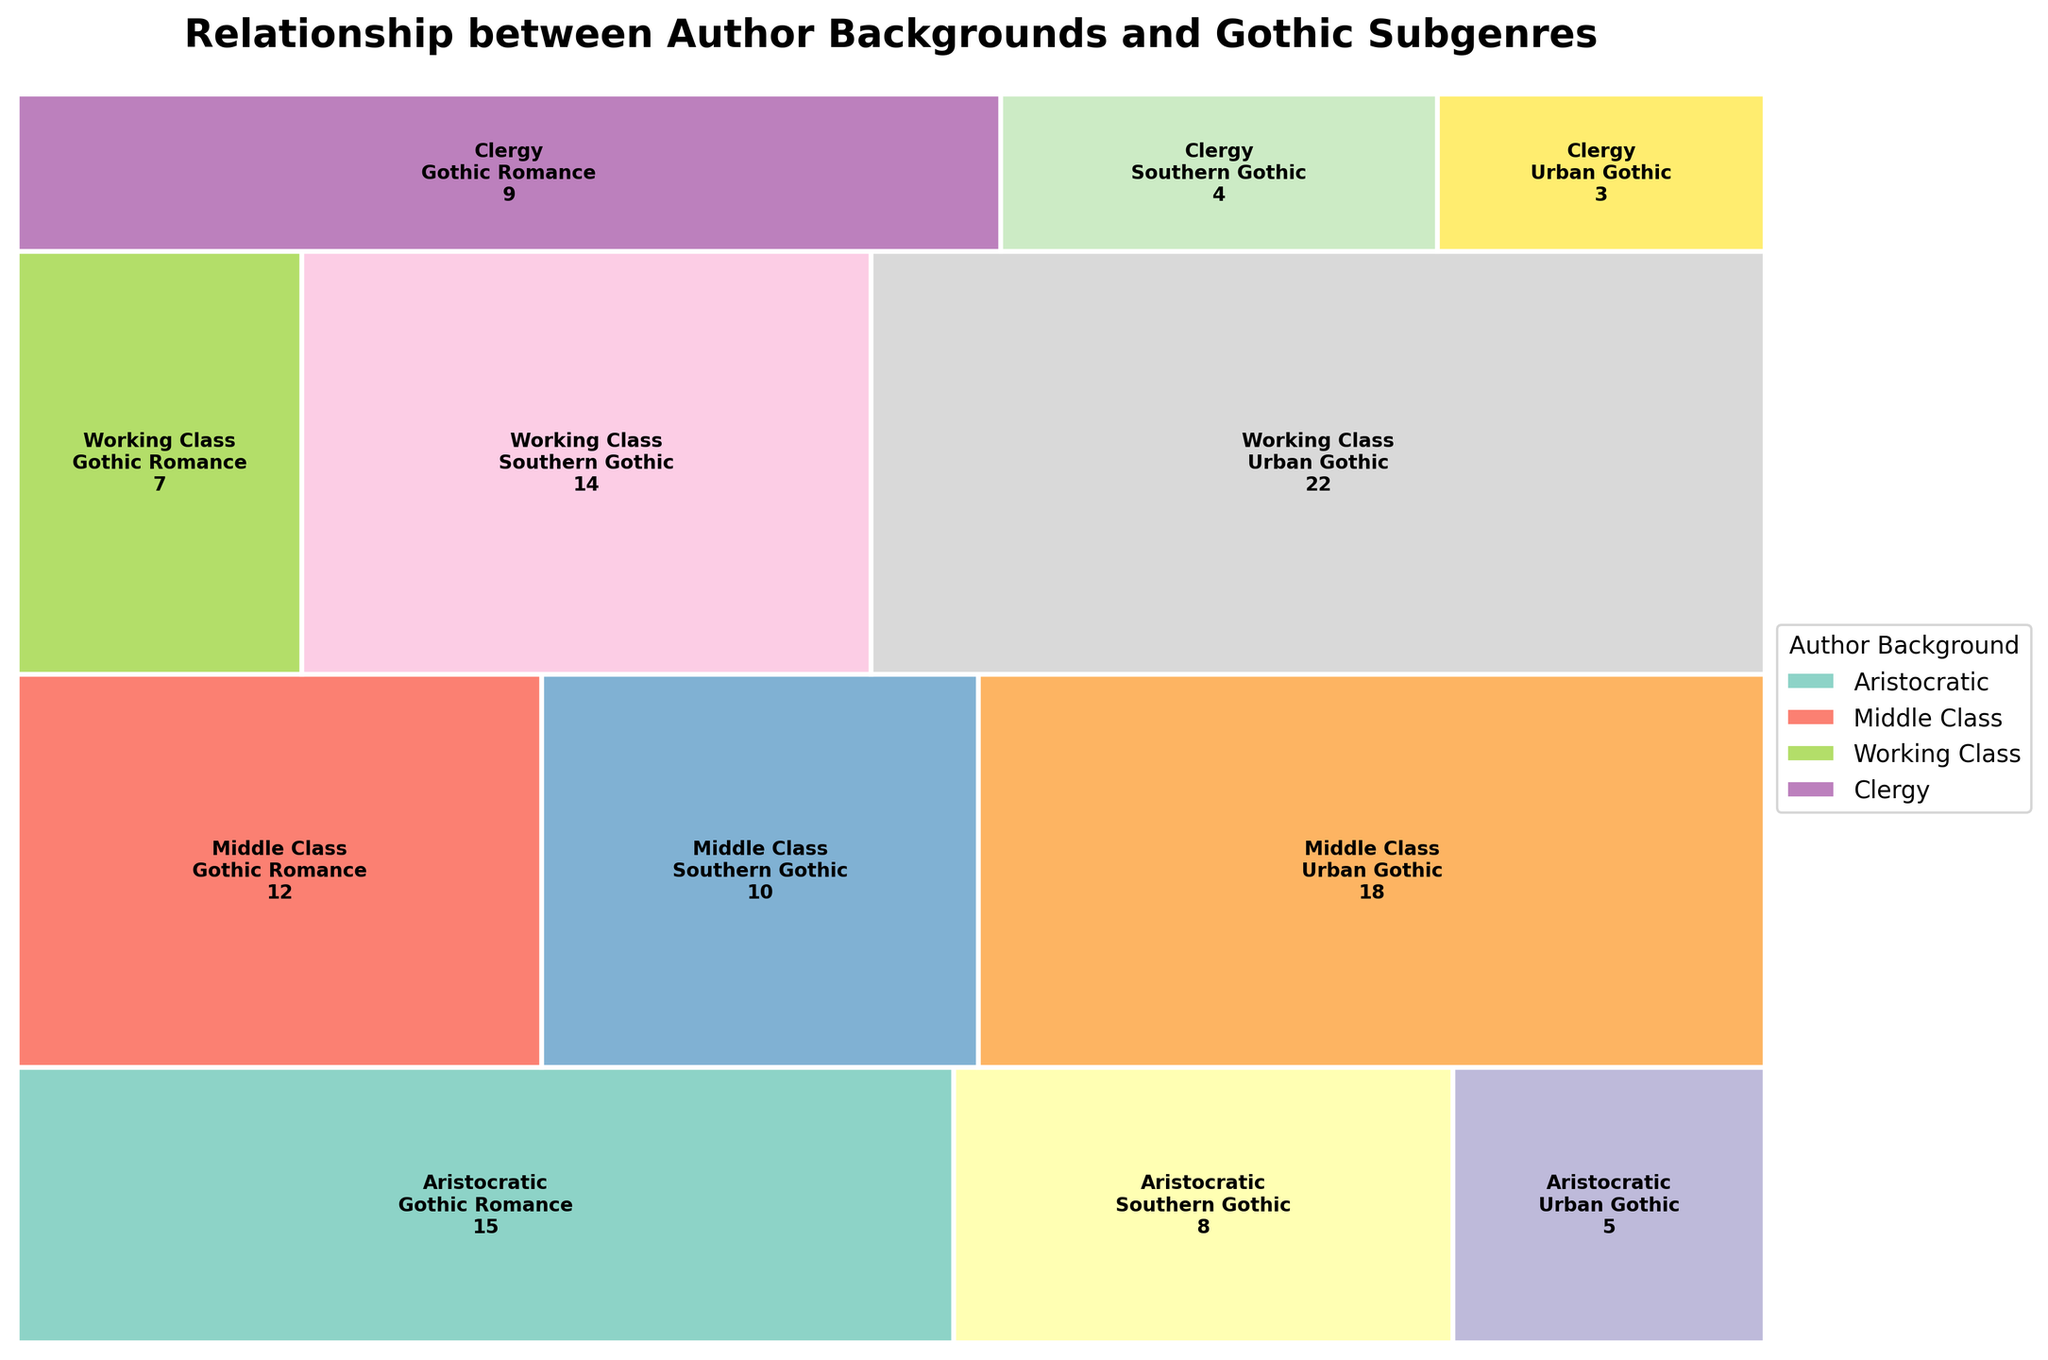What's the most common Gothic subgenre among aristocratic authors? By observing the size of the rectangles representing the subgenres for aristocratic authors, the largest area corresponds to Gothic Romance.
Answer: Gothic Romance How many Gothic Romance works are published by middle-class authors? The figure shows a rectangle labelled 'Middle Class' and 'Gothic Romance' with the number 12 inside it.
Answer: 12 Which author background contributes the most to Urban Gothic? By comparing the urban Gothic rectangles across author backgrounds, the working-class authors have the largest area dedicated to Urban Gothic.
Answer: Working Class What is the total count of Gothic works produced by clergy authors? Sum the counts for clergy authors across all subgenres: 9 (Gothic Romance) + 4 (Southern Gothic) + 3 (Urban Gothic) = 16.
Answer: 16 Which Gothic subgenre has the smallest representation among authors with a clergy background? The smallest rectangle for clergy authors is for Urban Gothic with a count of 3.
Answer: Urban Gothic Compare the number of Southern Gothic works by middle-class authors to working-class authors. The size of the rectangles for middle-class and working-class authors for Southern Gothic shows numbers 10 and 14 respectively. Middle-class is less than working-class.
Answer: Middle Class < Working Class Which subgenre is the most diverse in terms of author backgrounds? By considering the number of different author backgrounds contributing to each subgenre, all three Gothic subgenres show diversity, but Urban Gothic has the broadest representation since all backgrounds have significant contributions.
Answer: Urban Gothic Between aristocratic and working-class authors, who published more Gothic Romance works? Comparing the rectangles, aristocratic authors published 15 Gothic Romance works, while working-class authors published 7. Aristocratic is greater than working-class.
Answer: Aristocratic Calculate the total number of Gothic works by middle-class and working-class authors combined. Adding the totals for middle-class (12 + 10 + 18 = 40) and working-class (7 + 14 + 22 = 43) authors, the combined total is 40 + 43 = 83.
Answer: 83 What's the ratio of Gothic Romance works to Urban Gothic works among aristocratic authors? For aristocratic authors, count of Gothic Romance is 15 and count of Urban Gothic is 5. The ratio is 15:5 or 3:1.
Answer: 3:1 